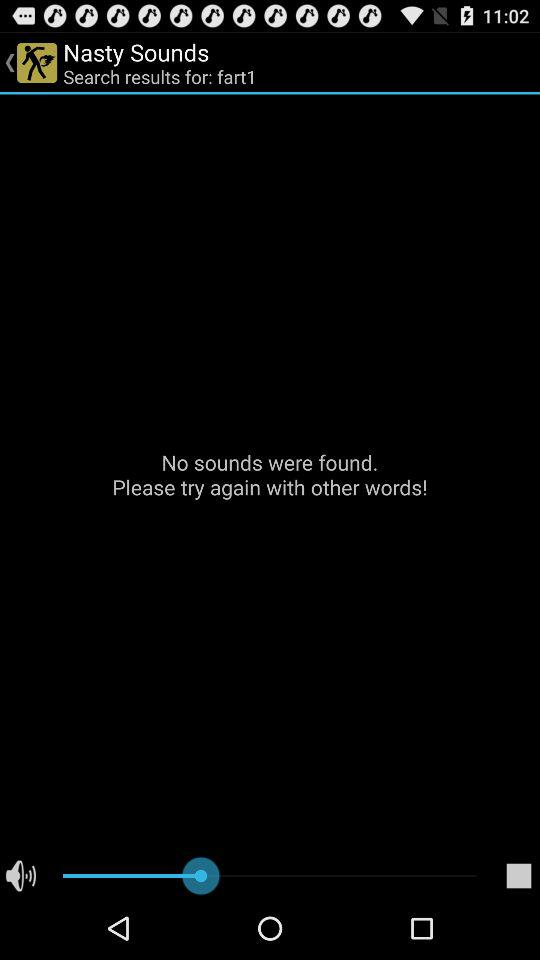What is the name of the application? The name of the application is "Nasty Sounds". 